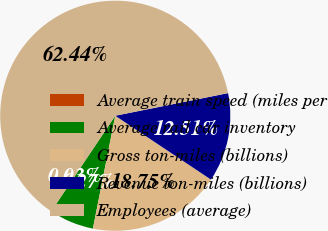<chart> <loc_0><loc_0><loc_500><loc_500><pie_chart><fcel>Average train speed (miles per<fcel>Average rail car inventory<fcel>Gross ton-miles (billions)<fcel>Revenue ton-miles (billions)<fcel>Employees (average)<nl><fcel>0.03%<fcel>6.27%<fcel>18.75%<fcel>12.51%<fcel>62.44%<nl></chart> 